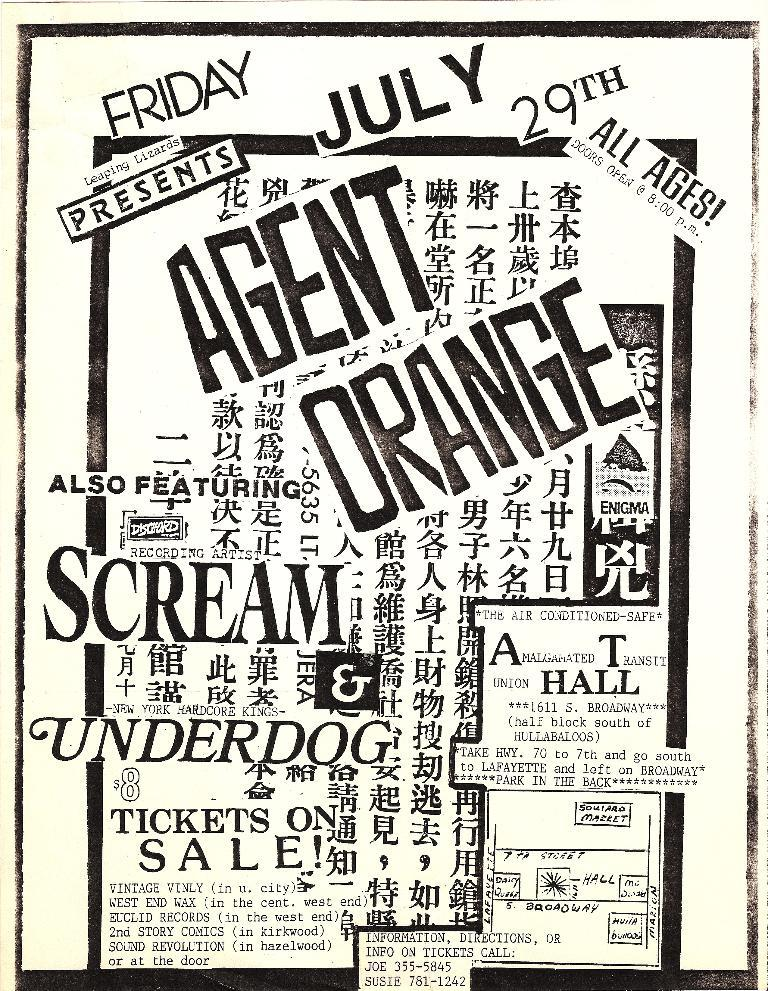<image>
Write a terse but informative summary of the picture. a music event poster for the band agent orange 